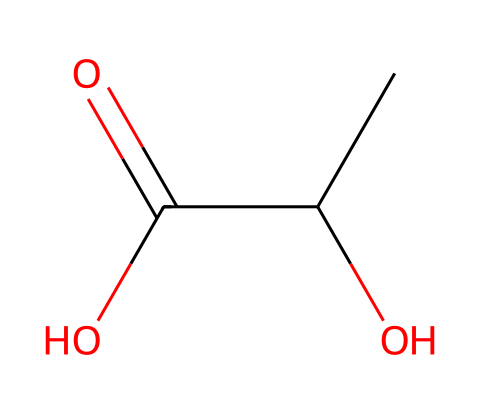What is the name of this chemical? This chemical has the structure of lactic acid, which is reflected in its name from the SMILES representation indicating a hydroxyl group (OH) and a carboxylic acid group (COOH).
Answer: lactic acid How many carbon atoms are present in this molecule? By analyzing the SMILES, the "CC" indicates two carbon atoms, and there are no other carbon groups mentioned. Therefore, there are two carbon atoms in total.
Answer: two What type of plastic does this chemical form? Lactic acid, when polymerized, forms polylactic acid (PLA), which is a biodegradable plastic known for its applications in utensils and packaging.
Answer: biodegradable plastic How many functional groups are present in this chemical structure? The SMILES representation shows one hydroxyl group (-OH) and one carboxylic acid group (-COOH), resulting in a total of two functional groups.
Answer: two Which property does the presence of the carboxylic acid group impart to the material? The carboxylic acid group enhances the material's biodegradability due to its ability to undergo hydrolysis under environmental conditions.
Answer: biodegradability What is the main advantage of using this polymer for utensils? PLA's main advantage is that it is derived from renewable resources and is compostable, reducing plastic waste in landfills when disposed of.
Answer: compostable 